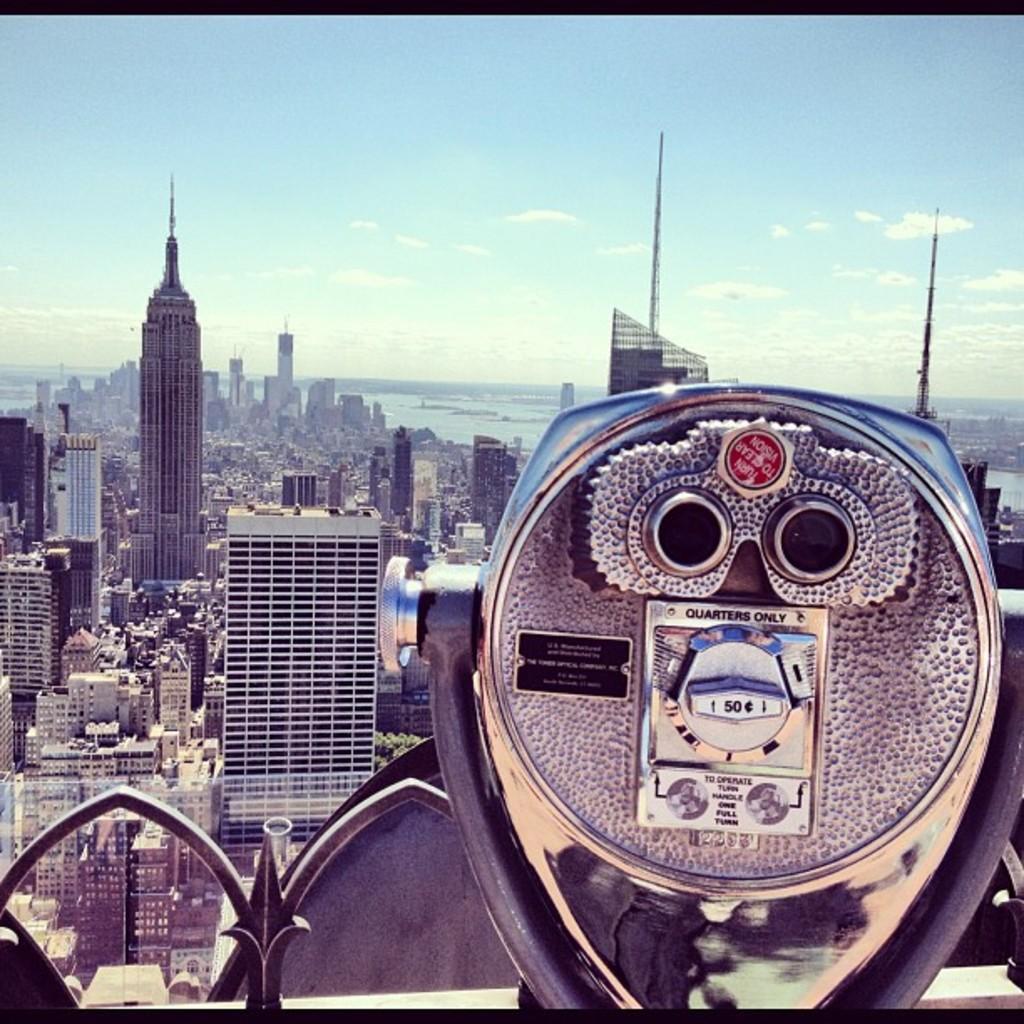In one or two sentences, can you explain what this image depicts? In this image, we can see binoculars and in the background, there are buildings, towers and trees and there is water. At the top, there are clouds in the sky. 